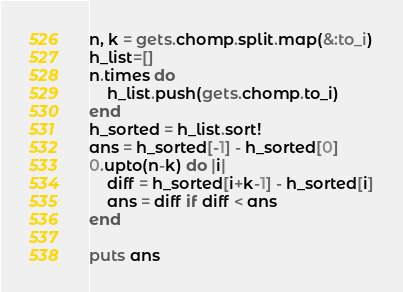Convert code to text. <code><loc_0><loc_0><loc_500><loc_500><_Ruby_>n, k = gets.chomp.split.map(&:to_i)
h_list=[]
n.times do
    h_list.push(gets.chomp.to_i)
end
h_sorted = h_list.sort!
ans = h_sorted[-1] - h_sorted[0]
0.upto(n-k) do |i|
    diff = h_sorted[i+k-1] - h_sorted[i]
    ans = diff if diff < ans
end

puts ans</code> 